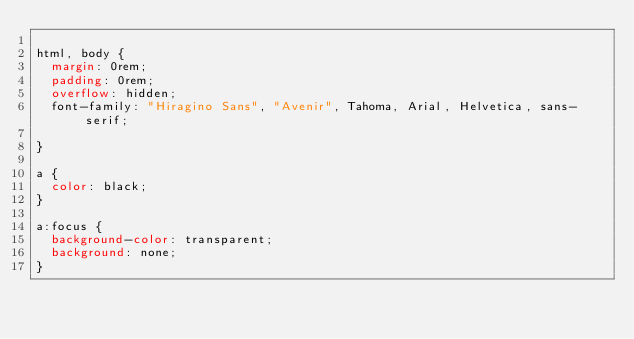<code> <loc_0><loc_0><loc_500><loc_500><_CSS_>
html, body {
  margin: 0rem;
  padding: 0rem;
  overflow: hidden;
  font-family: "Hiragino Sans", "Avenir", Tahoma, Arial, Helvetica, sans-serif;

}

a {
  color: black;
}

a:focus {
  background-color: transparent;
  background: none;
}</code> 